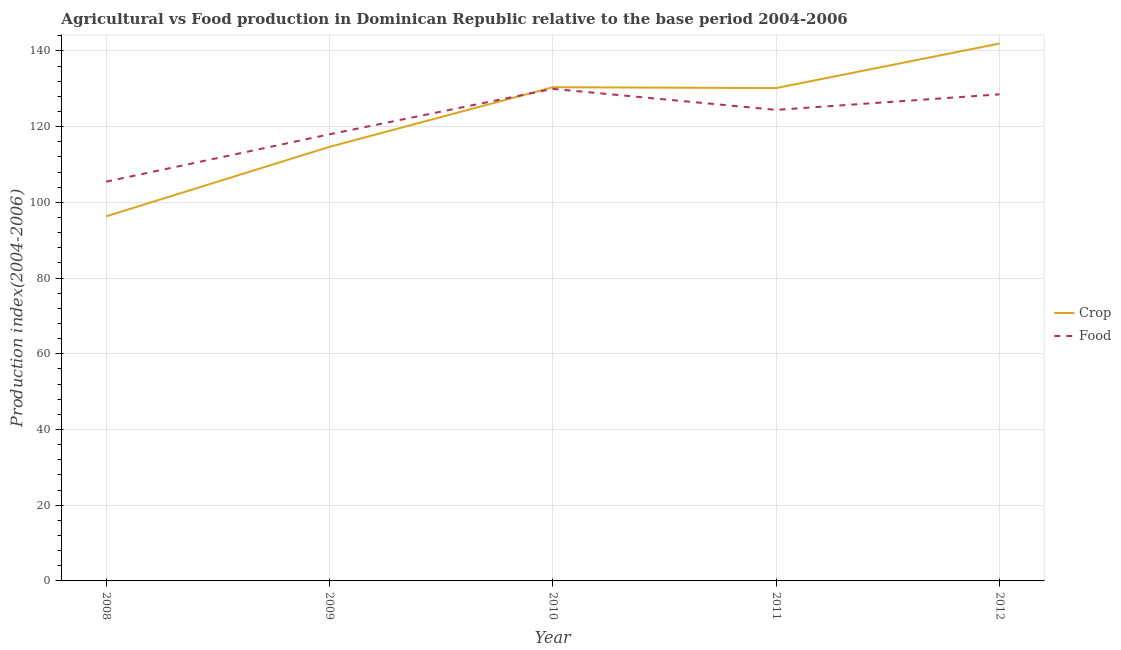Is the number of lines equal to the number of legend labels?
Keep it short and to the point. Yes. What is the food production index in 2010?
Provide a succinct answer. 129.96. Across all years, what is the maximum crop production index?
Make the answer very short. 141.94. Across all years, what is the minimum food production index?
Offer a terse response. 105.45. What is the total food production index in the graph?
Your answer should be very brief. 606.3. What is the difference between the crop production index in 2008 and that in 2010?
Offer a terse response. -34.11. What is the difference between the food production index in 2011 and the crop production index in 2008?
Keep it short and to the point. 28.12. What is the average food production index per year?
Your response must be concise. 121.26. In the year 2009, what is the difference between the food production index and crop production index?
Keep it short and to the point. 3.32. In how many years, is the food production index greater than 92?
Keep it short and to the point. 5. What is the ratio of the food production index in 2009 to that in 2011?
Give a very brief answer. 0.95. Is the difference between the crop production index in 2011 and 2012 greater than the difference between the food production index in 2011 and 2012?
Make the answer very short. No. What is the difference between the highest and the second highest food production index?
Ensure brevity in your answer.  1.44. What is the difference between the highest and the lowest food production index?
Offer a very short reply. 24.51. Does the food production index monotonically increase over the years?
Provide a short and direct response. No. How many years are there in the graph?
Provide a short and direct response. 5. What is the difference between two consecutive major ticks on the Y-axis?
Provide a short and direct response. 20. Does the graph contain any zero values?
Give a very brief answer. No. Does the graph contain grids?
Provide a succinct answer. Yes. What is the title of the graph?
Offer a very short reply. Agricultural vs Food production in Dominican Republic relative to the base period 2004-2006. Does "Female entrants" appear as one of the legend labels in the graph?
Provide a short and direct response. No. What is the label or title of the Y-axis?
Your response must be concise. Production index(2004-2006). What is the Production index(2004-2006) in Crop in 2008?
Your response must be concise. 96.29. What is the Production index(2004-2006) of Food in 2008?
Your answer should be very brief. 105.45. What is the Production index(2004-2006) in Crop in 2009?
Provide a succinct answer. 114.64. What is the Production index(2004-2006) of Food in 2009?
Make the answer very short. 117.96. What is the Production index(2004-2006) in Crop in 2010?
Offer a terse response. 130.4. What is the Production index(2004-2006) in Food in 2010?
Your answer should be very brief. 129.96. What is the Production index(2004-2006) in Crop in 2011?
Offer a very short reply. 130.17. What is the Production index(2004-2006) of Food in 2011?
Ensure brevity in your answer.  124.41. What is the Production index(2004-2006) of Crop in 2012?
Ensure brevity in your answer.  141.94. What is the Production index(2004-2006) of Food in 2012?
Provide a succinct answer. 128.52. Across all years, what is the maximum Production index(2004-2006) of Crop?
Your answer should be compact. 141.94. Across all years, what is the maximum Production index(2004-2006) of Food?
Your answer should be very brief. 129.96. Across all years, what is the minimum Production index(2004-2006) of Crop?
Keep it short and to the point. 96.29. Across all years, what is the minimum Production index(2004-2006) in Food?
Ensure brevity in your answer.  105.45. What is the total Production index(2004-2006) in Crop in the graph?
Provide a short and direct response. 613.44. What is the total Production index(2004-2006) in Food in the graph?
Offer a very short reply. 606.3. What is the difference between the Production index(2004-2006) in Crop in 2008 and that in 2009?
Offer a terse response. -18.35. What is the difference between the Production index(2004-2006) of Food in 2008 and that in 2009?
Give a very brief answer. -12.51. What is the difference between the Production index(2004-2006) in Crop in 2008 and that in 2010?
Provide a short and direct response. -34.11. What is the difference between the Production index(2004-2006) of Food in 2008 and that in 2010?
Provide a succinct answer. -24.51. What is the difference between the Production index(2004-2006) in Crop in 2008 and that in 2011?
Provide a short and direct response. -33.88. What is the difference between the Production index(2004-2006) of Food in 2008 and that in 2011?
Ensure brevity in your answer.  -18.96. What is the difference between the Production index(2004-2006) of Crop in 2008 and that in 2012?
Provide a succinct answer. -45.65. What is the difference between the Production index(2004-2006) of Food in 2008 and that in 2012?
Ensure brevity in your answer.  -23.07. What is the difference between the Production index(2004-2006) in Crop in 2009 and that in 2010?
Offer a very short reply. -15.76. What is the difference between the Production index(2004-2006) of Crop in 2009 and that in 2011?
Provide a short and direct response. -15.53. What is the difference between the Production index(2004-2006) in Food in 2009 and that in 2011?
Ensure brevity in your answer.  -6.45. What is the difference between the Production index(2004-2006) in Crop in 2009 and that in 2012?
Keep it short and to the point. -27.3. What is the difference between the Production index(2004-2006) in Food in 2009 and that in 2012?
Keep it short and to the point. -10.56. What is the difference between the Production index(2004-2006) in Crop in 2010 and that in 2011?
Your response must be concise. 0.23. What is the difference between the Production index(2004-2006) in Food in 2010 and that in 2011?
Ensure brevity in your answer.  5.55. What is the difference between the Production index(2004-2006) of Crop in 2010 and that in 2012?
Offer a very short reply. -11.54. What is the difference between the Production index(2004-2006) of Food in 2010 and that in 2012?
Make the answer very short. 1.44. What is the difference between the Production index(2004-2006) in Crop in 2011 and that in 2012?
Your answer should be compact. -11.77. What is the difference between the Production index(2004-2006) of Food in 2011 and that in 2012?
Your answer should be compact. -4.11. What is the difference between the Production index(2004-2006) in Crop in 2008 and the Production index(2004-2006) in Food in 2009?
Offer a very short reply. -21.67. What is the difference between the Production index(2004-2006) in Crop in 2008 and the Production index(2004-2006) in Food in 2010?
Provide a succinct answer. -33.67. What is the difference between the Production index(2004-2006) of Crop in 2008 and the Production index(2004-2006) of Food in 2011?
Keep it short and to the point. -28.12. What is the difference between the Production index(2004-2006) of Crop in 2008 and the Production index(2004-2006) of Food in 2012?
Give a very brief answer. -32.23. What is the difference between the Production index(2004-2006) of Crop in 2009 and the Production index(2004-2006) of Food in 2010?
Your response must be concise. -15.32. What is the difference between the Production index(2004-2006) of Crop in 2009 and the Production index(2004-2006) of Food in 2011?
Your answer should be very brief. -9.77. What is the difference between the Production index(2004-2006) of Crop in 2009 and the Production index(2004-2006) of Food in 2012?
Make the answer very short. -13.88. What is the difference between the Production index(2004-2006) of Crop in 2010 and the Production index(2004-2006) of Food in 2011?
Ensure brevity in your answer.  5.99. What is the difference between the Production index(2004-2006) of Crop in 2010 and the Production index(2004-2006) of Food in 2012?
Your response must be concise. 1.88. What is the difference between the Production index(2004-2006) of Crop in 2011 and the Production index(2004-2006) of Food in 2012?
Your answer should be compact. 1.65. What is the average Production index(2004-2006) in Crop per year?
Give a very brief answer. 122.69. What is the average Production index(2004-2006) in Food per year?
Offer a terse response. 121.26. In the year 2008, what is the difference between the Production index(2004-2006) of Crop and Production index(2004-2006) of Food?
Provide a short and direct response. -9.16. In the year 2009, what is the difference between the Production index(2004-2006) of Crop and Production index(2004-2006) of Food?
Keep it short and to the point. -3.32. In the year 2010, what is the difference between the Production index(2004-2006) of Crop and Production index(2004-2006) of Food?
Provide a succinct answer. 0.44. In the year 2011, what is the difference between the Production index(2004-2006) of Crop and Production index(2004-2006) of Food?
Your answer should be compact. 5.76. In the year 2012, what is the difference between the Production index(2004-2006) of Crop and Production index(2004-2006) of Food?
Your response must be concise. 13.42. What is the ratio of the Production index(2004-2006) of Crop in 2008 to that in 2009?
Offer a very short reply. 0.84. What is the ratio of the Production index(2004-2006) in Food in 2008 to that in 2009?
Provide a short and direct response. 0.89. What is the ratio of the Production index(2004-2006) in Crop in 2008 to that in 2010?
Offer a terse response. 0.74. What is the ratio of the Production index(2004-2006) of Food in 2008 to that in 2010?
Provide a succinct answer. 0.81. What is the ratio of the Production index(2004-2006) in Crop in 2008 to that in 2011?
Provide a short and direct response. 0.74. What is the ratio of the Production index(2004-2006) in Food in 2008 to that in 2011?
Your answer should be compact. 0.85. What is the ratio of the Production index(2004-2006) of Crop in 2008 to that in 2012?
Make the answer very short. 0.68. What is the ratio of the Production index(2004-2006) in Food in 2008 to that in 2012?
Offer a very short reply. 0.82. What is the ratio of the Production index(2004-2006) of Crop in 2009 to that in 2010?
Offer a terse response. 0.88. What is the ratio of the Production index(2004-2006) in Food in 2009 to that in 2010?
Provide a short and direct response. 0.91. What is the ratio of the Production index(2004-2006) of Crop in 2009 to that in 2011?
Your answer should be very brief. 0.88. What is the ratio of the Production index(2004-2006) in Food in 2009 to that in 2011?
Your answer should be very brief. 0.95. What is the ratio of the Production index(2004-2006) of Crop in 2009 to that in 2012?
Your response must be concise. 0.81. What is the ratio of the Production index(2004-2006) in Food in 2009 to that in 2012?
Your answer should be compact. 0.92. What is the ratio of the Production index(2004-2006) in Food in 2010 to that in 2011?
Offer a very short reply. 1.04. What is the ratio of the Production index(2004-2006) of Crop in 2010 to that in 2012?
Give a very brief answer. 0.92. What is the ratio of the Production index(2004-2006) in Food in 2010 to that in 2012?
Ensure brevity in your answer.  1.01. What is the ratio of the Production index(2004-2006) in Crop in 2011 to that in 2012?
Offer a terse response. 0.92. What is the difference between the highest and the second highest Production index(2004-2006) in Crop?
Make the answer very short. 11.54. What is the difference between the highest and the second highest Production index(2004-2006) of Food?
Your response must be concise. 1.44. What is the difference between the highest and the lowest Production index(2004-2006) of Crop?
Make the answer very short. 45.65. What is the difference between the highest and the lowest Production index(2004-2006) of Food?
Make the answer very short. 24.51. 